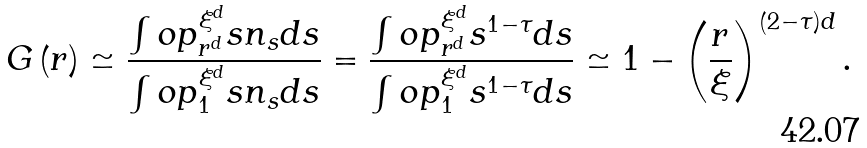Convert formula to latex. <formula><loc_0><loc_0><loc_500><loc_500>G \left ( r \right ) \simeq \frac { \int o p _ { r ^ { d } } ^ { \xi ^ { d } } s n _ { s } d s } { \int o p _ { 1 } ^ { \xi ^ { d } } s n _ { s } d s } = \frac { \int o p _ { r ^ { d } } ^ { \xi ^ { d } } s ^ { 1 - \tau } d s } { \int o p _ { 1 } ^ { \xi ^ { d } } s ^ { 1 - \tau } d s } \simeq 1 - \left ( \frac { r } { \xi } \right ) ^ { \left ( 2 - \tau \right ) d } .</formula> 